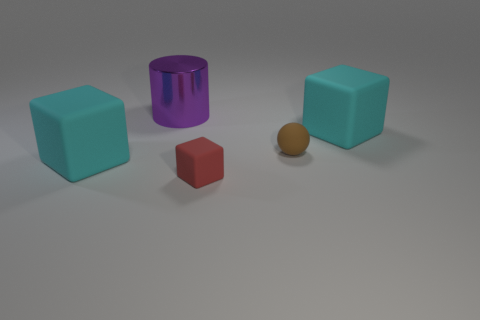There is a cyan rubber thing that is on the right side of the purple thing; what number of cyan cubes are on the left side of it?
Offer a very short reply. 1. What size is the brown ball that is made of the same material as the red object?
Make the answer very short. Small. The ball is what size?
Make the answer very short. Small. Are the cylinder and the red block made of the same material?
Ensure brevity in your answer.  No. What number of cubes are either purple shiny objects or small rubber objects?
Make the answer very short. 1. What color is the big matte block in front of the big cyan thing that is to the right of the purple cylinder?
Offer a terse response. Cyan. What number of large cyan objects are right of the big rubber block in front of the rubber cube to the right of the red object?
Offer a very short reply. 1. Does the big matte object to the right of the small brown matte sphere have the same shape as the tiny object to the left of the brown matte thing?
Keep it short and to the point. Yes. How many objects are metallic objects or small yellow matte things?
Your response must be concise. 1. What is the material of the cylinder left of the rubber object that is behind the tiny brown matte sphere?
Your answer should be very brief. Metal. 